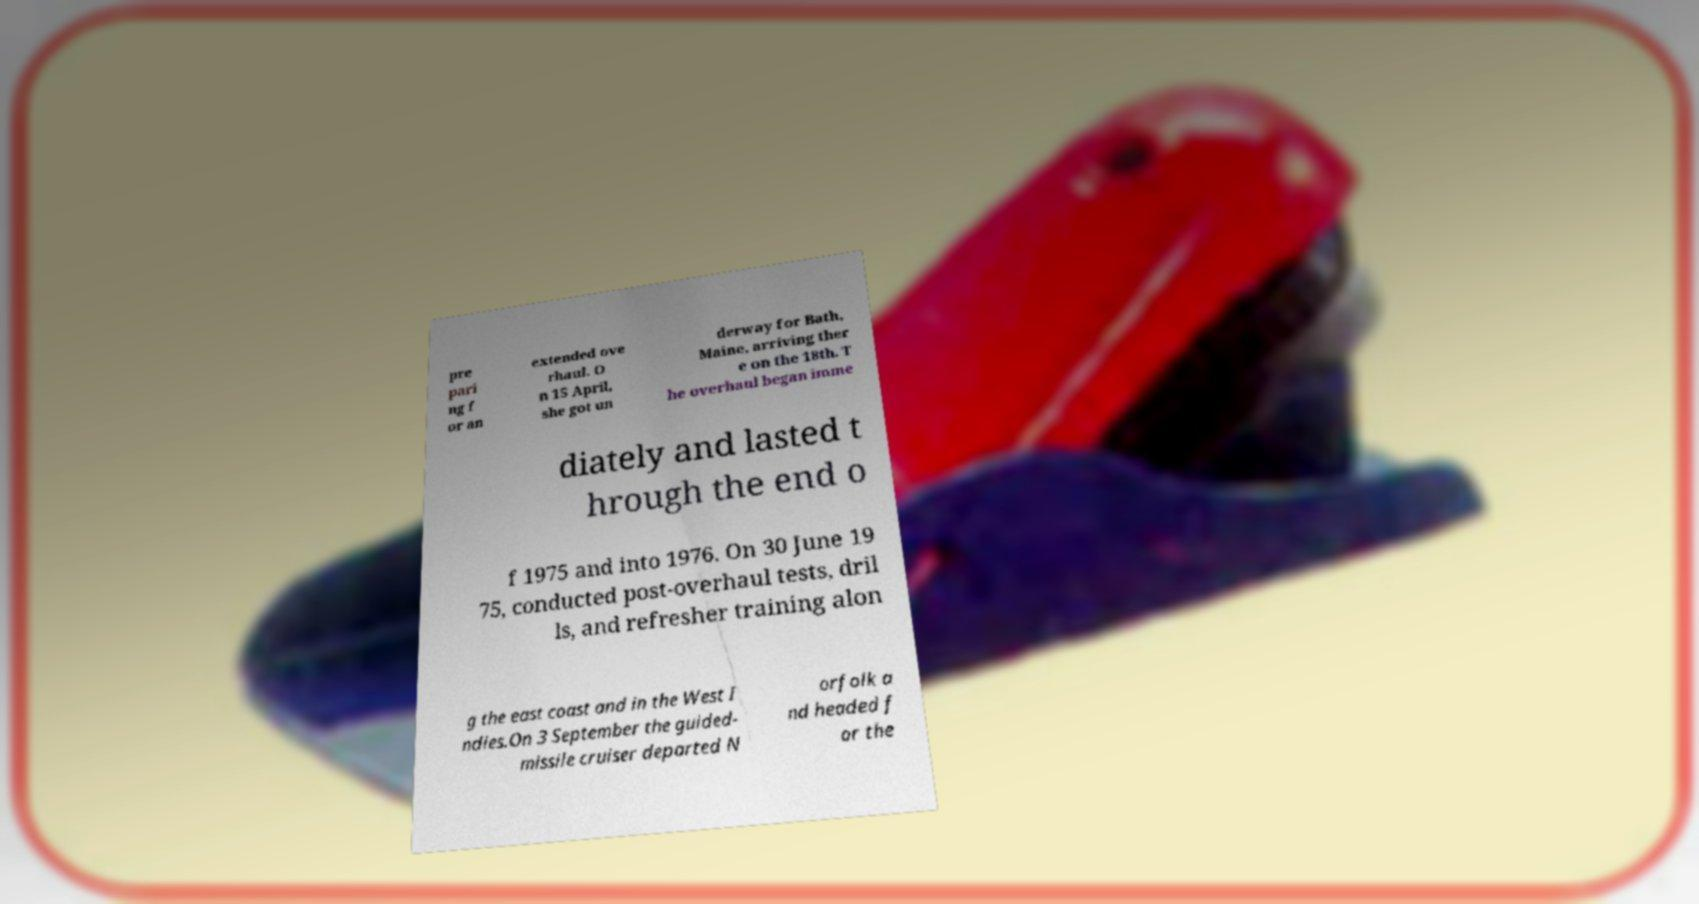Please read and relay the text visible in this image. What does it say? pre pari ng f or an extended ove rhaul. O n 15 April, she got un derway for Bath, Maine, arriving ther e on the 18th. T he overhaul began imme diately and lasted t hrough the end o f 1975 and into 1976. On 30 June 19 75, conducted post-overhaul tests, dril ls, and refresher training alon g the east coast and in the West I ndies.On 3 September the guided- missile cruiser departed N orfolk a nd headed f or the 